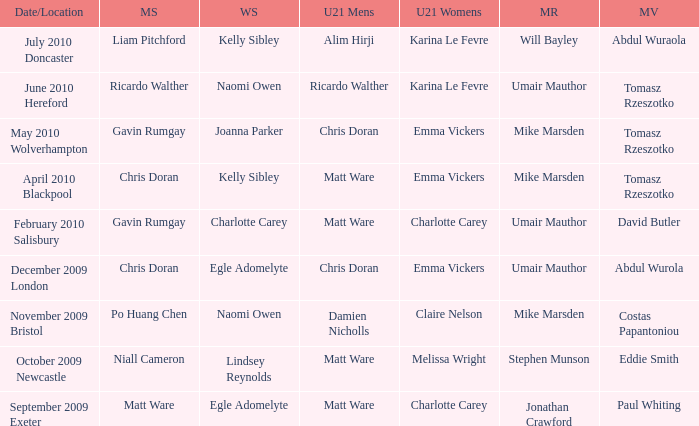Would you mind parsing the complete table? {'header': ['Date/Location', 'MS', 'WS', 'U21 Mens', 'U21 Womens', 'MR', 'MV'], 'rows': [['July 2010 Doncaster', 'Liam Pitchford', 'Kelly Sibley', 'Alim Hirji', 'Karina Le Fevre', 'Will Bayley', 'Abdul Wuraola'], ['June 2010 Hereford', 'Ricardo Walther', 'Naomi Owen', 'Ricardo Walther', 'Karina Le Fevre', 'Umair Mauthor', 'Tomasz Rzeszotko'], ['May 2010 Wolverhampton', 'Gavin Rumgay', 'Joanna Parker', 'Chris Doran', 'Emma Vickers', 'Mike Marsden', 'Tomasz Rzeszotko'], ['April 2010 Blackpool', 'Chris Doran', 'Kelly Sibley', 'Matt Ware', 'Emma Vickers', 'Mike Marsden', 'Tomasz Rzeszotko'], ['February 2010 Salisbury', 'Gavin Rumgay', 'Charlotte Carey', 'Matt Ware', 'Charlotte Carey', 'Umair Mauthor', 'David Butler'], ['December 2009 London', 'Chris Doran', 'Egle Adomelyte', 'Chris Doran', 'Emma Vickers', 'Umair Mauthor', 'Abdul Wurola'], ['November 2009 Bristol', 'Po Huang Chen', 'Naomi Owen', 'Damien Nicholls', 'Claire Nelson', 'Mike Marsden', 'Costas Papantoniou'], ['October 2009 Newcastle', 'Niall Cameron', 'Lindsey Reynolds', 'Matt Ware', 'Melissa Wright', 'Stephen Munson', 'Eddie Smith'], ['September 2009 Exeter', 'Matt Ware', 'Egle Adomelyte', 'Matt Ware', 'Charlotte Carey', 'Jonathan Crawford', 'Paul Whiting']]} When Naomi Owen won the Womens Singles and Ricardo Walther won the Mens Singles, who won the mixed veteran? Tomasz Rzeszotko. 